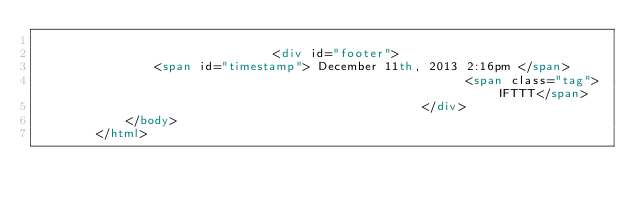Convert code to text. <code><loc_0><loc_0><loc_500><loc_500><_HTML_>                
                                <div id="footer">
                <span id="timestamp"> December 11th, 2013 2:16pm </span>
                                                          <span class="tag">IFTTT</span>
                                                    </div>
            </body>
        </html>

        </code> 